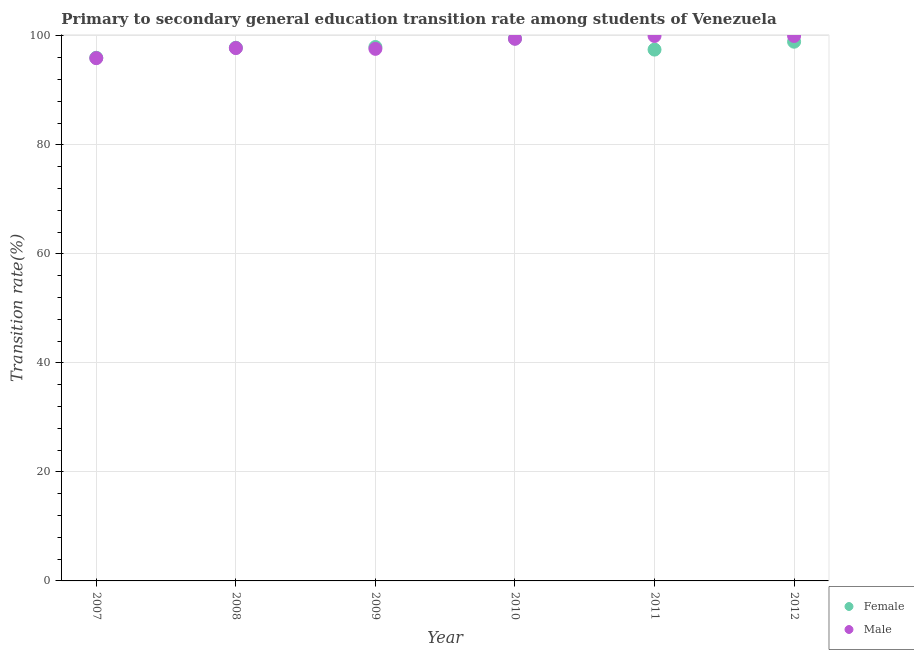Is the number of dotlines equal to the number of legend labels?
Provide a succinct answer. Yes. What is the transition rate among male students in 2009?
Ensure brevity in your answer.  97.64. Across all years, what is the minimum transition rate among female students?
Ensure brevity in your answer.  96. In which year was the transition rate among female students maximum?
Your answer should be very brief. 2010. In which year was the transition rate among male students minimum?
Ensure brevity in your answer.  2007. What is the total transition rate among female students in the graph?
Make the answer very short. 587.8. What is the difference between the transition rate among male students in 2008 and that in 2011?
Ensure brevity in your answer.  -2.22. What is the difference between the transition rate among male students in 2011 and the transition rate among female students in 2009?
Your answer should be compact. 2.02. What is the average transition rate among female students per year?
Offer a terse response. 97.97. In the year 2010, what is the difference between the transition rate among male students and transition rate among female students?
Ensure brevity in your answer.  -0.05. What is the ratio of the transition rate among female students in 2007 to that in 2010?
Provide a short and direct response. 0.96. What is the difference between the highest and the lowest transition rate among female students?
Offer a terse response. 3.53. Is the transition rate among female students strictly greater than the transition rate among male students over the years?
Ensure brevity in your answer.  No. Is the transition rate among male students strictly less than the transition rate among female students over the years?
Your answer should be very brief. No. How many dotlines are there?
Provide a short and direct response. 2. What is the difference between two consecutive major ticks on the Y-axis?
Make the answer very short. 20. Does the graph contain any zero values?
Provide a succinct answer. No. Does the graph contain grids?
Your response must be concise. Yes. Where does the legend appear in the graph?
Your response must be concise. Bottom right. How many legend labels are there?
Offer a terse response. 2. How are the legend labels stacked?
Offer a very short reply. Vertical. What is the title of the graph?
Offer a terse response. Primary to secondary general education transition rate among students of Venezuela. What is the label or title of the Y-axis?
Offer a terse response. Transition rate(%). What is the Transition rate(%) in Female in 2007?
Ensure brevity in your answer.  96. What is the Transition rate(%) of Male in 2007?
Your answer should be compact. 95.93. What is the Transition rate(%) of Female in 2008?
Offer a very short reply. 97.84. What is the Transition rate(%) in Male in 2008?
Ensure brevity in your answer.  97.78. What is the Transition rate(%) of Female in 2009?
Offer a very short reply. 97.98. What is the Transition rate(%) in Male in 2009?
Make the answer very short. 97.64. What is the Transition rate(%) of Female in 2010?
Keep it short and to the point. 99.53. What is the Transition rate(%) of Male in 2010?
Your response must be concise. 99.49. What is the Transition rate(%) of Female in 2011?
Give a very brief answer. 97.5. What is the Transition rate(%) in Female in 2012?
Offer a very short reply. 98.95. Across all years, what is the maximum Transition rate(%) in Female?
Your response must be concise. 99.53. Across all years, what is the minimum Transition rate(%) in Female?
Your answer should be compact. 96. Across all years, what is the minimum Transition rate(%) of Male?
Provide a succinct answer. 95.93. What is the total Transition rate(%) in Female in the graph?
Ensure brevity in your answer.  587.8. What is the total Transition rate(%) of Male in the graph?
Provide a succinct answer. 590.84. What is the difference between the Transition rate(%) in Female in 2007 and that in 2008?
Ensure brevity in your answer.  -1.84. What is the difference between the Transition rate(%) in Male in 2007 and that in 2008?
Offer a very short reply. -1.85. What is the difference between the Transition rate(%) of Female in 2007 and that in 2009?
Ensure brevity in your answer.  -1.98. What is the difference between the Transition rate(%) of Male in 2007 and that in 2009?
Provide a succinct answer. -1.71. What is the difference between the Transition rate(%) in Female in 2007 and that in 2010?
Offer a terse response. -3.53. What is the difference between the Transition rate(%) in Male in 2007 and that in 2010?
Offer a terse response. -3.56. What is the difference between the Transition rate(%) of Female in 2007 and that in 2011?
Give a very brief answer. -1.5. What is the difference between the Transition rate(%) of Male in 2007 and that in 2011?
Your response must be concise. -4.07. What is the difference between the Transition rate(%) in Female in 2007 and that in 2012?
Offer a terse response. -2.95. What is the difference between the Transition rate(%) in Male in 2007 and that in 2012?
Provide a short and direct response. -4.07. What is the difference between the Transition rate(%) in Female in 2008 and that in 2009?
Your answer should be compact. -0.14. What is the difference between the Transition rate(%) in Male in 2008 and that in 2009?
Offer a terse response. 0.14. What is the difference between the Transition rate(%) in Female in 2008 and that in 2010?
Make the answer very short. -1.69. What is the difference between the Transition rate(%) of Male in 2008 and that in 2010?
Your answer should be compact. -1.71. What is the difference between the Transition rate(%) in Female in 2008 and that in 2011?
Your response must be concise. 0.34. What is the difference between the Transition rate(%) of Male in 2008 and that in 2011?
Offer a terse response. -2.22. What is the difference between the Transition rate(%) in Female in 2008 and that in 2012?
Provide a succinct answer. -1.11. What is the difference between the Transition rate(%) of Male in 2008 and that in 2012?
Offer a terse response. -2.22. What is the difference between the Transition rate(%) of Female in 2009 and that in 2010?
Offer a very short reply. -1.56. What is the difference between the Transition rate(%) in Male in 2009 and that in 2010?
Offer a terse response. -1.85. What is the difference between the Transition rate(%) of Female in 2009 and that in 2011?
Provide a succinct answer. 0.48. What is the difference between the Transition rate(%) in Male in 2009 and that in 2011?
Your response must be concise. -2.36. What is the difference between the Transition rate(%) of Female in 2009 and that in 2012?
Give a very brief answer. -0.97. What is the difference between the Transition rate(%) of Male in 2009 and that in 2012?
Keep it short and to the point. -2.36. What is the difference between the Transition rate(%) in Female in 2010 and that in 2011?
Make the answer very short. 2.03. What is the difference between the Transition rate(%) of Male in 2010 and that in 2011?
Your answer should be very brief. -0.51. What is the difference between the Transition rate(%) in Female in 2010 and that in 2012?
Your answer should be very brief. 0.59. What is the difference between the Transition rate(%) in Male in 2010 and that in 2012?
Your response must be concise. -0.51. What is the difference between the Transition rate(%) in Female in 2011 and that in 2012?
Keep it short and to the point. -1.45. What is the difference between the Transition rate(%) of Male in 2011 and that in 2012?
Provide a short and direct response. 0. What is the difference between the Transition rate(%) in Female in 2007 and the Transition rate(%) in Male in 2008?
Provide a succinct answer. -1.78. What is the difference between the Transition rate(%) of Female in 2007 and the Transition rate(%) of Male in 2009?
Keep it short and to the point. -1.64. What is the difference between the Transition rate(%) of Female in 2007 and the Transition rate(%) of Male in 2010?
Your answer should be compact. -3.49. What is the difference between the Transition rate(%) in Female in 2007 and the Transition rate(%) in Male in 2011?
Offer a terse response. -4. What is the difference between the Transition rate(%) in Female in 2007 and the Transition rate(%) in Male in 2012?
Provide a short and direct response. -4. What is the difference between the Transition rate(%) of Female in 2008 and the Transition rate(%) of Male in 2009?
Your response must be concise. 0.2. What is the difference between the Transition rate(%) in Female in 2008 and the Transition rate(%) in Male in 2010?
Provide a succinct answer. -1.65. What is the difference between the Transition rate(%) of Female in 2008 and the Transition rate(%) of Male in 2011?
Provide a succinct answer. -2.16. What is the difference between the Transition rate(%) in Female in 2008 and the Transition rate(%) in Male in 2012?
Ensure brevity in your answer.  -2.16. What is the difference between the Transition rate(%) in Female in 2009 and the Transition rate(%) in Male in 2010?
Your answer should be very brief. -1.51. What is the difference between the Transition rate(%) in Female in 2009 and the Transition rate(%) in Male in 2011?
Provide a succinct answer. -2.02. What is the difference between the Transition rate(%) in Female in 2009 and the Transition rate(%) in Male in 2012?
Ensure brevity in your answer.  -2.02. What is the difference between the Transition rate(%) in Female in 2010 and the Transition rate(%) in Male in 2011?
Your answer should be compact. -0.47. What is the difference between the Transition rate(%) in Female in 2010 and the Transition rate(%) in Male in 2012?
Keep it short and to the point. -0.47. What is the difference between the Transition rate(%) in Female in 2011 and the Transition rate(%) in Male in 2012?
Give a very brief answer. -2.5. What is the average Transition rate(%) of Female per year?
Make the answer very short. 97.97. What is the average Transition rate(%) of Male per year?
Provide a short and direct response. 98.47. In the year 2007, what is the difference between the Transition rate(%) in Female and Transition rate(%) in Male?
Offer a very short reply. 0.07. In the year 2008, what is the difference between the Transition rate(%) in Female and Transition rate(%) in Male?
Provide a short and direct response. 0.06. In the year 2009, what is the difference between the Transition rate(%) of Female and Transition rate(%) of Male?
Your answer should be compact. 0.34. In the year 2010, what is the difference between the Transition rate(%) of Female and Transition rate(%) of Male?
Ensure brevity in your answer.  0.05. In the year 2011, what is the difference between the Transition rate(%) of Female and Transition rate(%) of Male?
Provide a short and direct response. -2.5. In the year 2012, what is the difference between the Transition rate(%) of Female and Transition rate(%) of Male?
Offer a very short reply. -1.05. What is the ratio of the Transition rate(%) in Female in 2007 to that in 2008?
Ensure brevity in your answer.  0.98. What is the ratio of the Transition rate(%) in Male in 2007 to that in 2008?
Your answer should be very brief. 0.98. What is the ratio of the Transition rate(%) of Female in 2007 to that in 2009?
Give a very brief answer. 0.98. What is the ratio of the Transition rate(%) in Male in 2007 to that in 2009?
Your answer should be compact. 0.98. What is the ratio of the Transition rate(%) in Female in 2007 to that in 2010?
Offer a terse response. 0.96. What is the ratio of the Transition rate(%) of Male in 2007 to that in 2010?
Your response must be concise. 0.96. What is the ratio of the Transition rate(%) in Female in 2007 to that in 2011?
Provide a short and direct response. 0.98. What is the ratio of the Transition rate(%) in Male in 2007 to that in 2011?
Give a very brief answer. 0.96. What is the ratio of the Transition rate(%) of Female in 2007 to that in 2012?
Give a very brief answer. 0.97. What is the ratio of the Transition rate(%) in Male in 2007 to that in 2012?
Provide a short and direct response. 0.96. What is the ratio of the Transition rate(%) in Female in 2008 to that in 2009?
Keep it short and to the point. 1. What is the ratio of the Transition rate(%) of Male in 2008 to that in 2009?
Provide a succinct answer. 1. What is the ratio of the Transition rate(%) of Male in 2008 to that in 2010?
Keep it short and to the point. 0.98. What is the ratio of the Transition rate(%) in Female in 2008 to that in 2011?
Offer a very short reply. 1. What is the ratio of the Transition rate(%) in Male in 2008 to that in 2011?
Keep it short and to the point. 0.98. What is the ratio of the Transition rate(%) of Male in 2008 to that in 2012?
Provide a succinct answer. 0.98. What is the ratio of the Transition rate(%) of Female in 2009 to that in 2010?
Your answer should be very brief. 0.98. What is the ratio of the Transition rate(%) of Male in 2009 to that in 2010?
Provide a succinct answer. 0.98. What is the ratio of the Transition rate(%) in Male in 2009 to that in 2011?
Offer a terse response. 0.98. What is the ratio of the Transition rate(%) in Female in 2009 to that in 2012?
Provide a succinct answer. 0.99. What is the ratio of the Transition rate(%) in Male in 2009 to that in 2012?
Provide a short and direct response. 0.98. What is the ratio of the Transition rate(%) of Female in 2010 to that in 2011?
Make the answer very short. 1.02. What is the ratio of the Transition rate(%) in Female in 2010 to that in 2012?
Provide a short and direct response. 1.01. What is the ratio of the Transition rate(%) of Female in 2011 to that in 2012?
Make the answer very short. 0.99. What is the difference between the highest and the second highest Transition rate(%) in Female?
Your response must be concise. 0.59. What is the difference between the highest and the second highest Transition rate(%) of Male?
Provide a short and direct response. 0. What is the difference between the highest and the lowest Transition rate(%) in Female?
Provide a short and direct response. 3.53. What is the difference between the highest and the lowest Transition rate(%) in Male?
Ensure brevity in your answer.  4.07. 